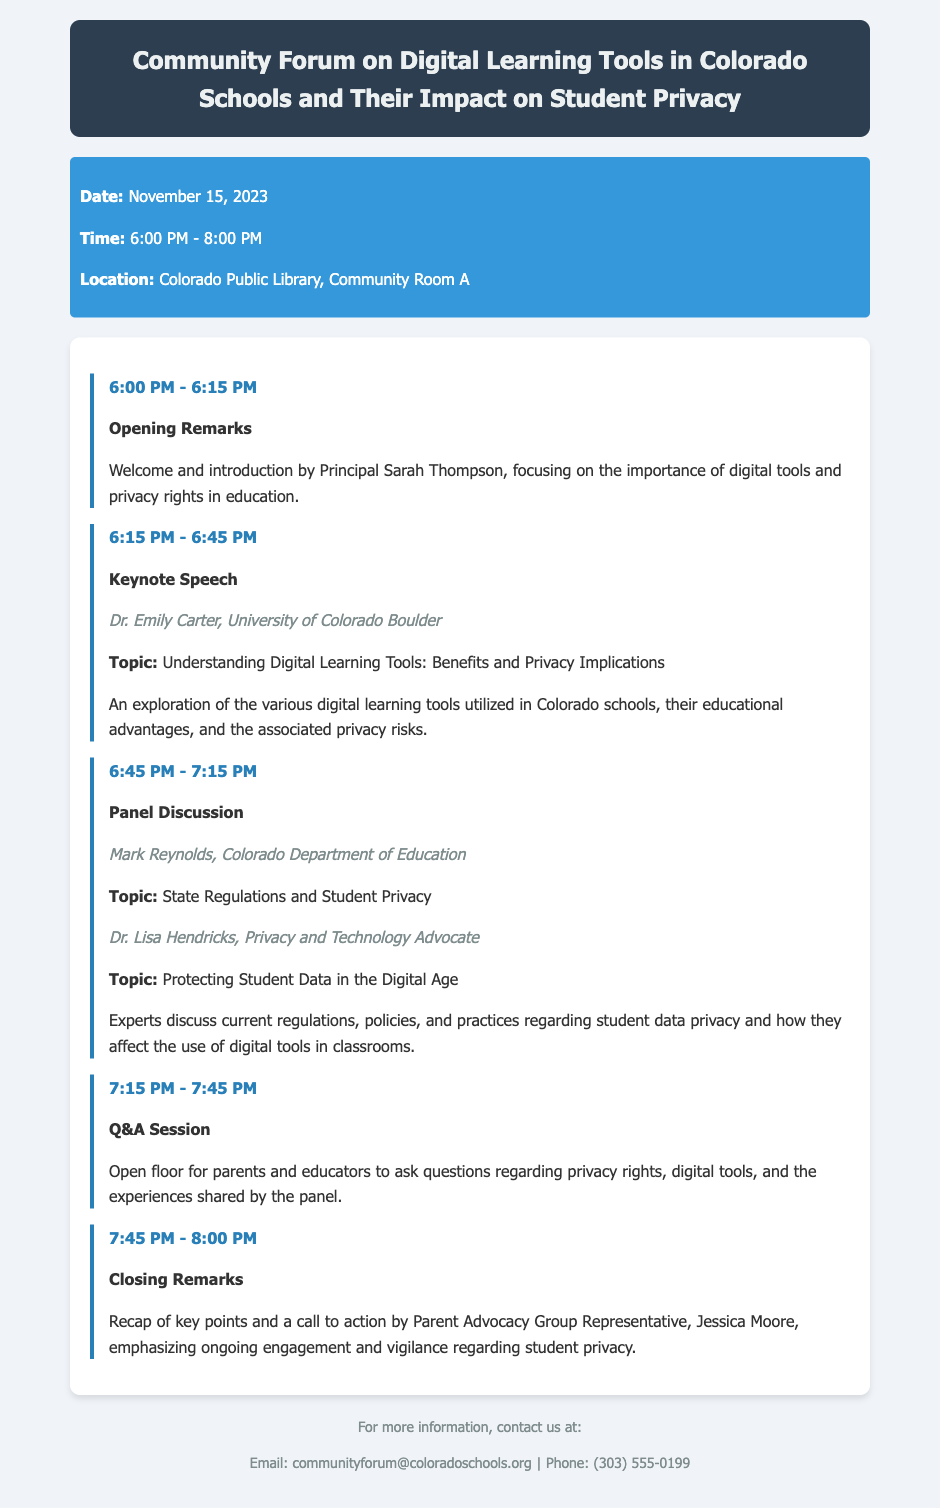What is the date of the forum? The date of the forum is specifically stated in the event details section of the document.
Answer: November 15, 2023 Who is giving the keynote speech? The speaker's name for the keynote speech is mentioned along with their affiliation in the agenda.
Answer: Dr. Emily Carter What time does the Q&A session start? The timing for the Q&A session can be found in the agenda, detailing its start time.
Answer: 7:15 PM What organization is Mark Reynolds affiliated with? The affiliation of the panelist Mark Reynolds is stated in the panel discussion section.
Answer: Colorado Department of Education What is the main topic of Dr. Lisa Hendricks' discussion? The topic presented by Dr. Lisa Hendricks is provided alongside her name in the agenda.
Answer: Protecting Student Data in the Digital Age What is emphasized in the closing remarks? The content of the closing remarks is summarized in the activities section towards the end of the agenda.
Answer: Ongoing engagement and vigilance regarding student privacy 